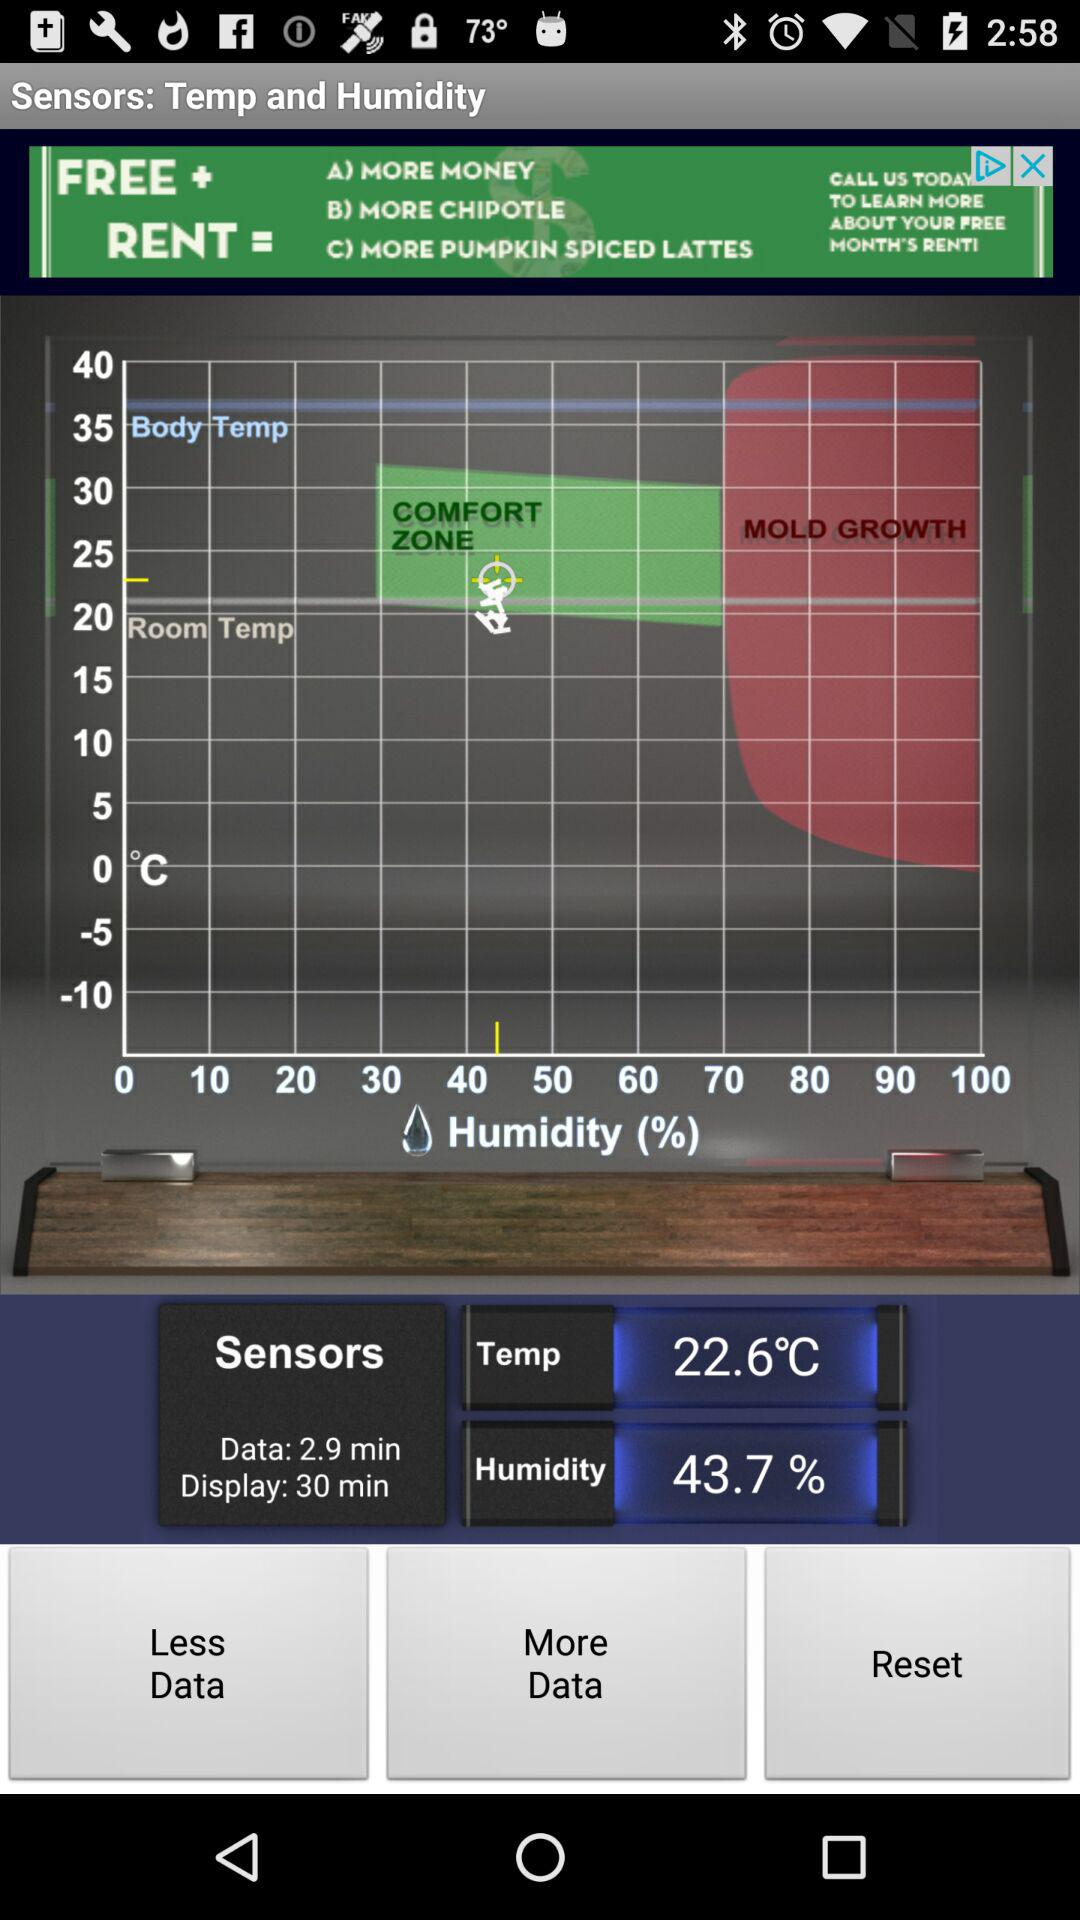What is the display time? The display time is 30 minutes. 